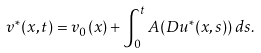<formula> <loc_0><loc_0><loc_500><loc_500>v ^ { * } ( x , t ) = v _ { 0 } ( x ) + \int _ { 0 } ^ { t } A ( D u ^ { * } ( x , s ) ) \, d s .</formula> 